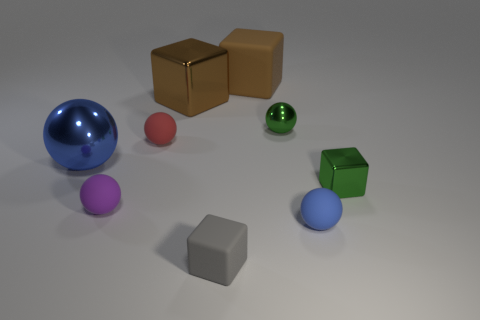Is the tiny shiny block the same color as the tiny matte block?
Offer a terse response. No. What size is the brown shiny cube?
Give a very brief answer. Large. How many big metal cubes have the same color as the big matte block?
Provide a succinct answer. 1. There is a blue ball right of the matte block behind the red sphere; are there any tiny green metallic spheres in front of it?
Ensure brevity in your answer.  No. What shape is the gray rubber thing that is the same size as the red matte thing?
Your answer should be compact. Cube. How many tiny things are either blue matte balls or red rubber balls?
Your answer should be compact. 2. There is a large cube that is the same material as the tiny blue ball; what is its color?
Your answer should be compact. Brown. There is a tiny shiny object on the right side of the small blue sphere; does it have the same shape as the big object right of the brown shiny cube?
Ensure brevity in your answer.  Yes. How many rubber things are either small green things or small green balls?
Offer a very short reply. 0. There is a object that is the same color as the big ball; what is it made of?
Provide a short and direct response. Rubber. 